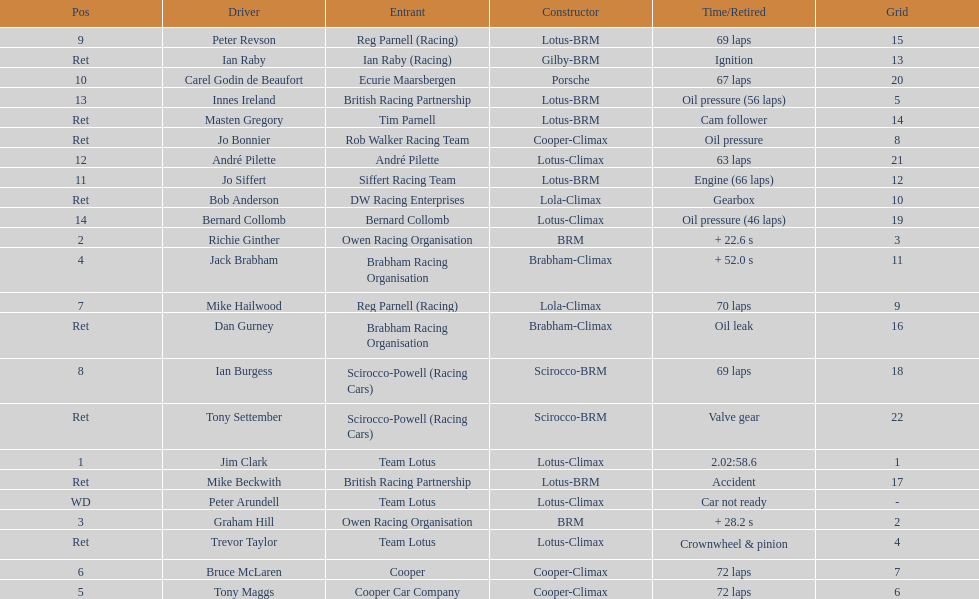Which driver did not have his/her car ready? Peter Arundell. 